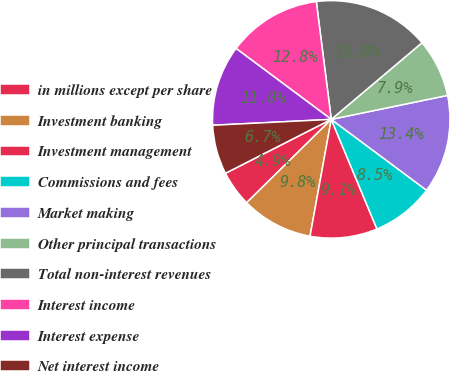Convert chart. <chart><loc_0><loc_0><loc_500><loc_500><pie_chart><fcel>in millions except per share<fcel>Investment banking<fcel>Investment management<fcel>Commissions and fees<fcel>Market making<fcel>Other principal transactions<fcel>Total non-interest revenues<fcel>Interest income<fcel>Interest expense<fcel>Net interest income<nl><fcel>4.88%<fcel>9.76%<fcel>9.15%<fcel>8.54%<fcel>13.41%<fcel>7.93%<fcel>15.85%<fcel>12.8%<fcel>10.98%<fcel>6.71%<nl></chart> 